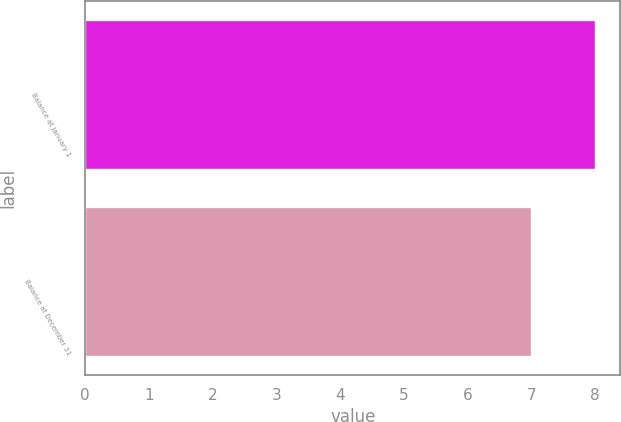Convert chart to OTSL. <chart><loc_0><loc_0><loc_500><loc_500><bar_chart><fcel>Balance at January 1<fcel>Balance at December 31<nl><fcel>8<fcel>7<nl></chart> 